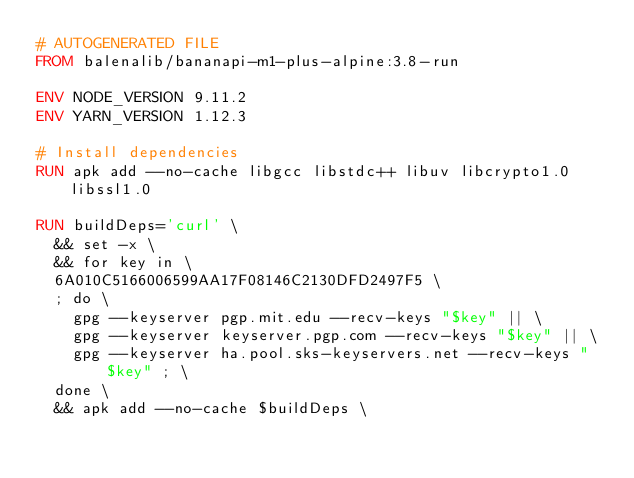Convert code to text. <code><loc_0><loc_0><loc_500><loc_500><_Dockerfile_># AUTOGENERATED FILE
FROM balenalib/bananapi-m1-plus-alpine:3.8-run

ENV NODE_VERSION 9.11.2
ENV YARN_VERSION 1.12.3

# Install dependencies
RUN apk add --no-cache libgcc libstdc++ libuv libcrypto1.0 libssl1.0

RUN buildDeps='curl' \
	&& set -x \
	&& for key in \
	6A010C5166006599AA17F08146C2130DFD2497F5 \
	; do \
		gpg --keyserver pgp.mit.edu --recv-keys "$key" || \
		gpg --keyserver keyserver.pgp.com --recv-keys "$key" || \
		gpg --keyserver ha.pool.sks-keyservers.net --recv-keys "$key" ; \
	done \
	&& apk add --no-cache $buildDeps \</code> 